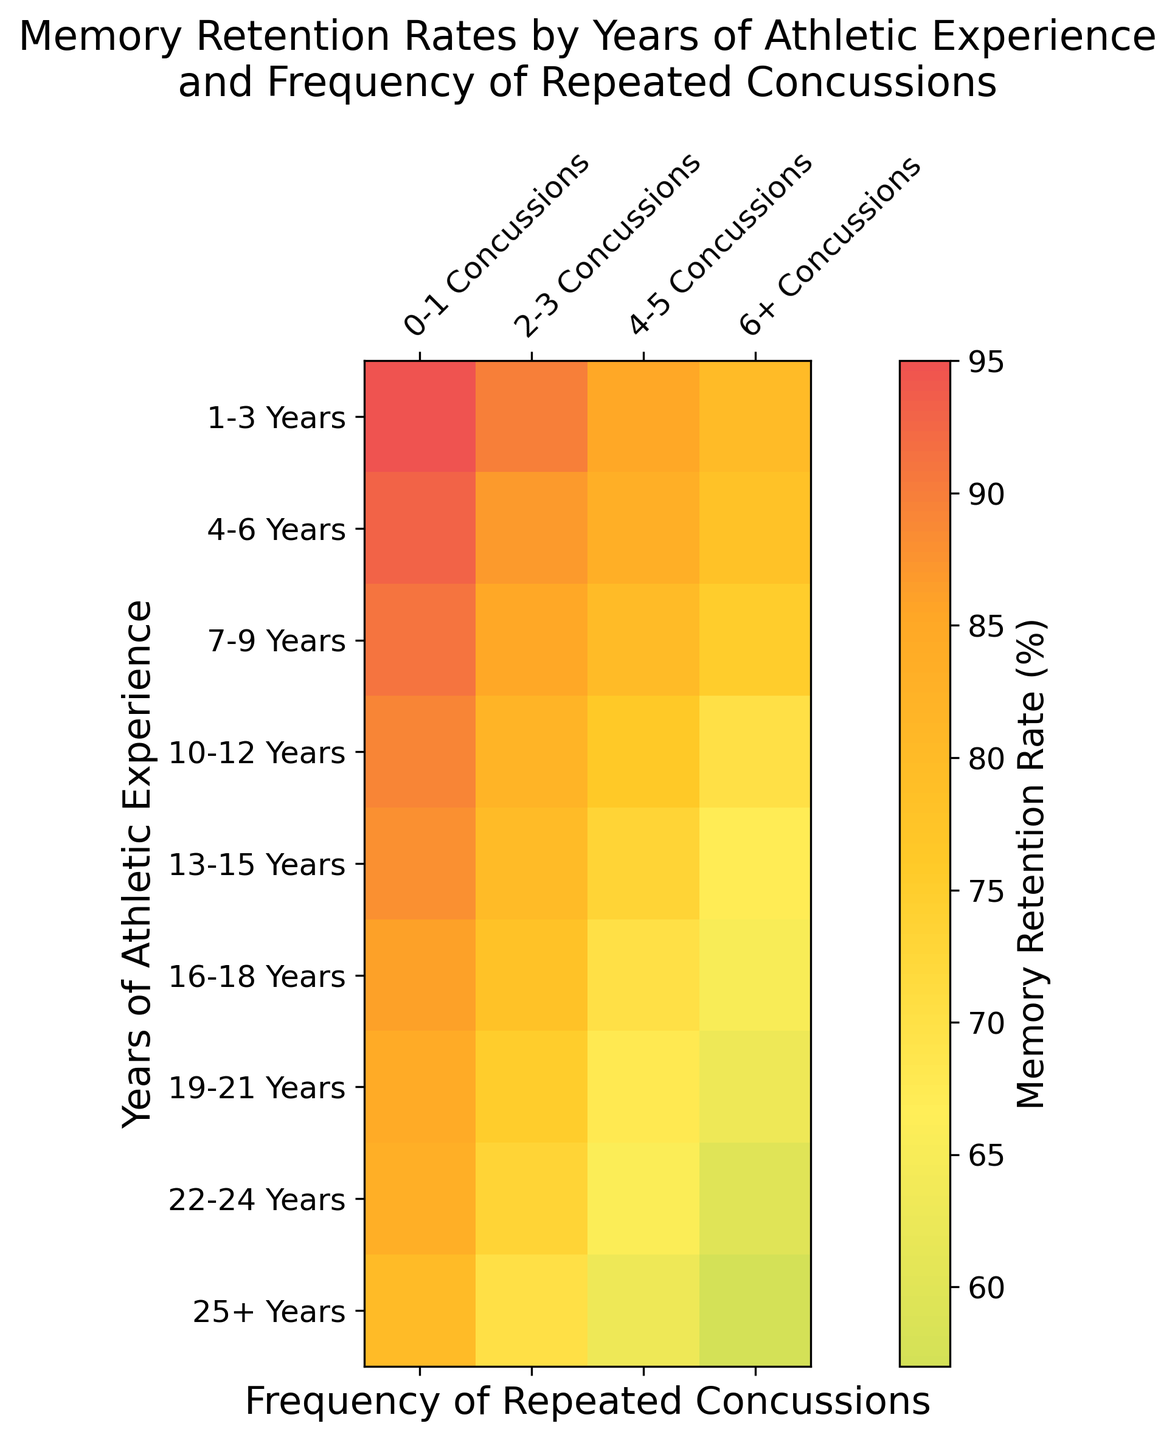What's the average memory retention rate for athletes with 6+ concussions across all years of athletic experience? To calculate this, sum the memory retention rates for "6+ Concussions" across all years and divide by the number of data points. The sum is (80 + 78 + 75 + 70 + 67 + 65 + 63 + 60 + 57) = 615. There are 9 data points, so the average is 615 / 9 ≈ 68.3
Answer: 68.3 Which group has the highest memory retention rate? The highest value on the heatmap is 95, which falls in the "0-1 Concussions" category for "1-3 Years" of athletic experience.
Answer: 1-3 Years, 0-1 Concussions How does memory retention change from 0-1 concussions to 6+ concussions in athletes with 10-12 years of experience? For athletes with 10-12 years of experience, the memory retention rate decreases from 89 (0-1 Concussions) to 70 (6+ Concussions). The difference is 89 - 70 = 19.
Answer: Decreases by 19 Compare the memory retention rates between athletes with 4-6 years and 16-18 years of experience for the same number of concussions across categories. For 0-1 concussions: 93 (4-6 years) vs. 86 (16-18 years); for 2-3 concussions: 87 (4-6 years) vs. 78 (16-18 years); for 4-5 concussions: 83 (4-6 years) vs. 70 (16-18 years); for 6+ concussions: 78 (4-6 years) vs. 65 (16-18 years). Memory retention is higher for 4-6 years in each category.
Answer: Higher for 4-6 years in each category What is the difference in memory retention rates between athletes with 13-15 years of experience who have had 0-1 concussions and those with 6+ concussions? For athletes with 13-15 years of experience: 0-1 concussions have a rate of 88, and 6+ concussions have a rate of 67. The difference is 88 - 67 = 21.
Answer: 21 Which category has the lowest memory retention rate and what is it? The lowest memory retention rate on the heatmap is 57, which is found in the "6+ Concussions" category for "25+ Years" of athletic experience.
Answer: 25+ Years, 6+ Concussions What is the overall trend in memory retention as years of athletic experience increase for the 0-1 concussions category? The memory retention rate tends to decrease gradually as the years of athletic experience increase within the 0-1 concussions category. It starts at 95 (1-3 years) and goes down to 80 (25+ years).
Answer: Decreases Compare the color intensity for athletes with 7-9 years of experience and 6+ concussions to those with 19-21 years of experience and 0-1 concussions. Describe what this signifies. Athletes with 7-9 years of experience and 6+ concussions have a darker red color (indicating lower retention) compared to the lighter greenish color for those with 19-21 years of experience and 0-1 concussions (indicating higher retention). This signifies that higher concussion frequencies lead to lower memory retention rates regardless of the experience years.
Answer: Significant drop in retention with higher concussions 